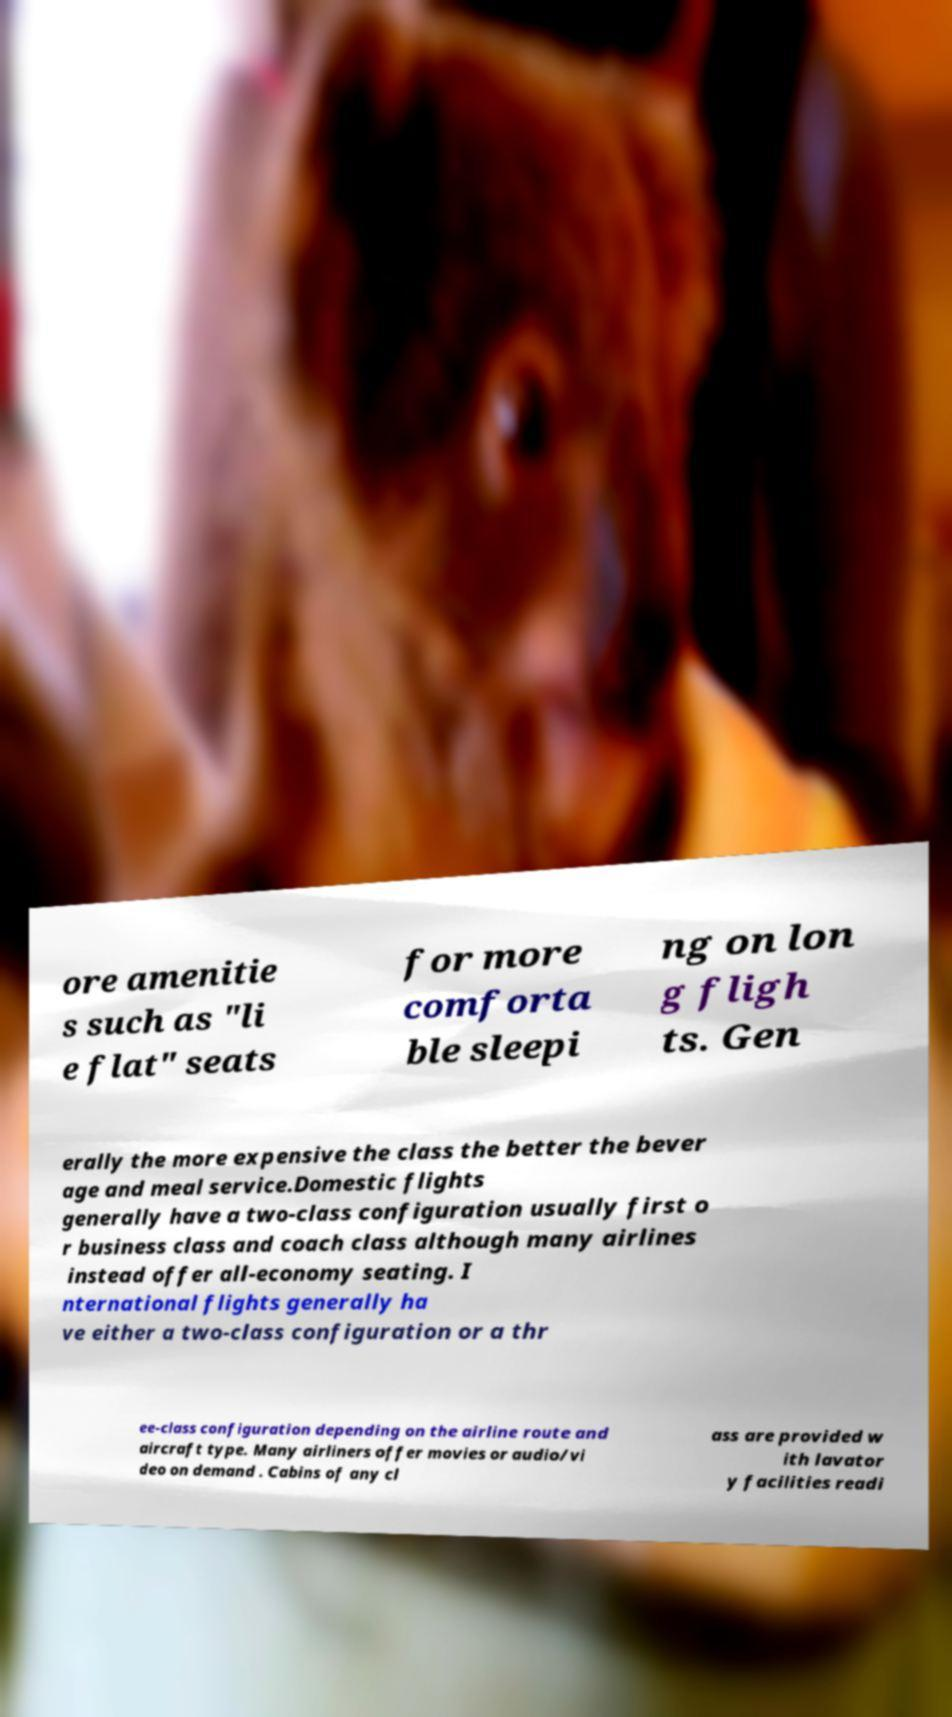For documentation purposes, I need the text within this image transcribed. Could you provide that? ore amenitie s such as "li e flat" seats for more comforta ble sleepi ng on lon g fligh ts. Gen erally the more expensive the class the better the bever age and meal service.Domestic flights generally have a two-class configuration usually first o r business class and coach class although many airlines instead offer all-economy seating. I nternational flights generally ha ve either a two-class configuration or a thr ee-class configuration depending on the airline route and aircraft type. Many airliners offer movies or audio/vi deo on demand . Cabins of any cl ass are provided w ith lavator y facilities readi 